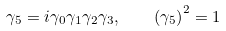Convert formula to latex. <formula><loc_0><loc_0><loc_500><loc_500>\gamma _ { 5 } = i \gamma _ { 0 } \gamma _ { 1 } \gamma _ { 2 } \gamma _ { 3 } , \quad \left ( \gamma _ { 5 } \right ) ^ { 2 } = 1</formula> 